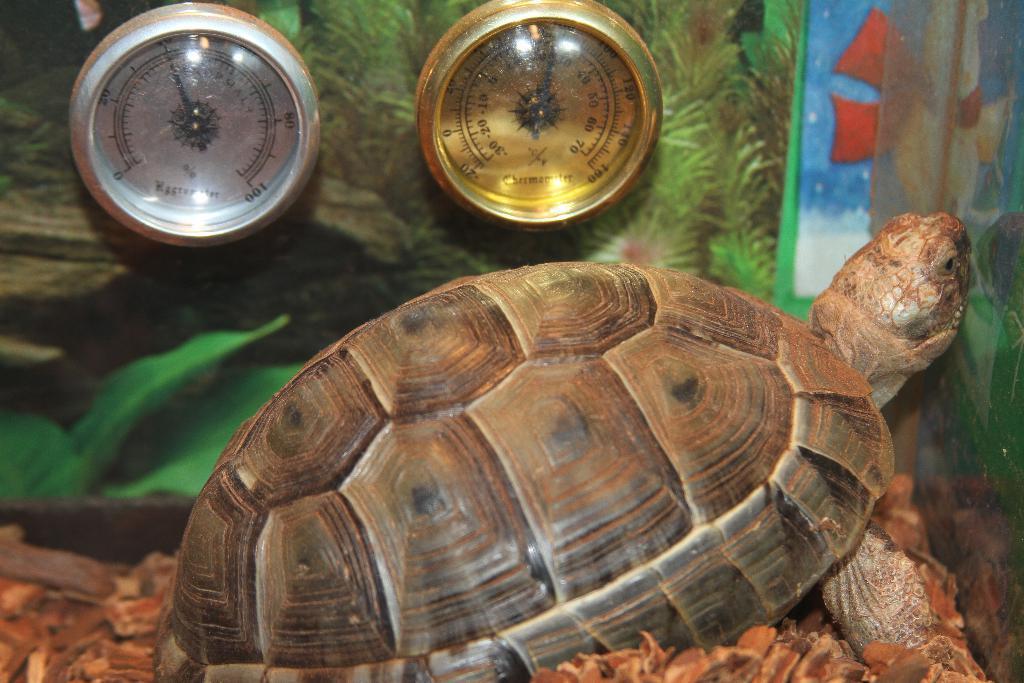In one or two sentences, can you explain what this image depicts? In this picture there is a tortoise and there are two objects beside it and there are some other objects below it. 